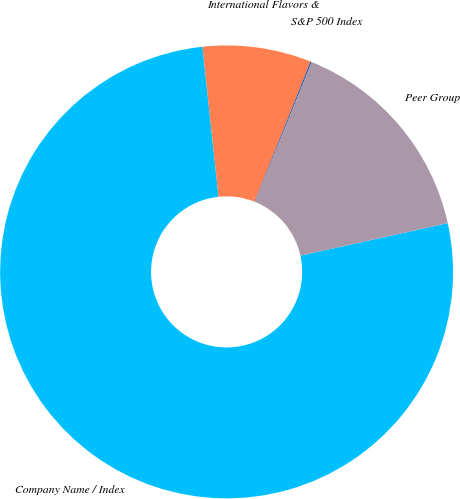Convert chart to OTSL. <chart><loc_0><loc_0><loc_500><loc_500><pie_chart><fcel>Company Name / Index<fcel>International Flavors &<fcel>S&P 500 Index<fcel>Peer Group<nl><fcel>76.76%<fcel>7.75%<fcel>0.08%<fcel>15.42%<nl></chart> 